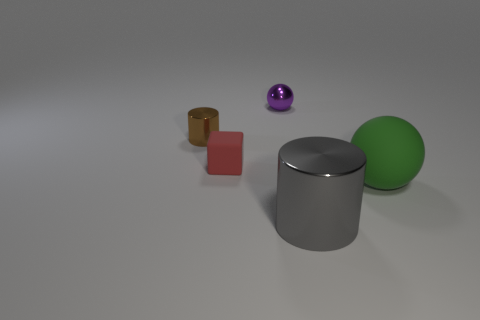Add 2 large green matte objects. How many objects exist? 7 Subtract all cylinders. How many objects are left? 3 Subtract 0 blue balls. How many objects are left? 5 Subtract all cyan cylinders. Subtract all yellow cubes. How many cylinders are left? 2 Subtract all big balls. Subtract all tiny cubes. How many objects are left? 3 Add 5 large green spheres. How many large green spheres are left? 6 Add 4 big cyan rubber blocks. How many big cyan rubber blocks exist? 4 